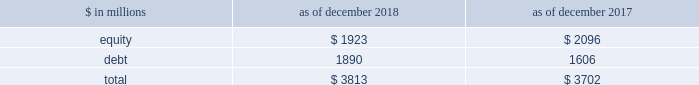The goldman sachs group , inc .
And subsidiaries management 2019s discussion and analysis during periods in which we have significantly more positive net revenue days than net revenue loss days , we expect to have fewer var exceptions because , under normal conditions , our business model generally produces positive net revenues .
In periods in which our franchise revenues are adversely affected , we generally have more loss days , resulting in more var exceptions .
The daily net revenues for positions included in var used to determine var exceptions reflect the impact of any intraday activity , including bid/offer net revenues , which are more likely than not to be positive by their nature .
Sensitivity measures certain portfolios and individual positions are not included in var because var is not the most appropriate risk measure .
Other sensitivity measures we use to analyze market risk are described below .
10% ( 10 % ) sensitivity measures .
The table below presents market risk by asset category for positions accounted for at fair value , that are not included in var. .
In the table above : 2030 the market risk of these positions is determined by estimating the potential reduction in net revenues of a 10% ( 10 % ) decline in the value of these positions .
2030 equity positions relate to private and restricted public equity securities , including interests in funds that invest in corporate equities and real estate and interests in hedge funds .
2030 debt positions include interests in funds that invest in corporate mezzanine and senior debt instruments , loans backed by commercial and residential real estate , corporate bank loans and other corporate debt , including acquired portfolios of distressed loans .
2030 funded equity and debt positions are included in our consolidated statements of financial condition in financial instruments owned .
See note 6 to the consolidated financial statements for further information about cash instruments .
2030 these measures do not reflect the diversification effect across asset categories or across other market risk measures .
Credit spread sensitivity on derivatives and financial liabilities .
Var excludes the impact of changes in counterparty and our own credit spreads on derivatives , as well as changes in our own credit spreads ( debt valuation adjustment ) on financial liabilities for which the fair value option was elected .
The estimated sensitivity to a one basis point increase in credit spreads ( counterparty and our own ) on derivatives was a gain of $ 3 million ( including hedges ) as of both december 2018 and december 2017 .
In addition , the estimated sensitivity to a one basis point increase in our own credit spreads on financial liabilities for which the fair value option was elected was a gain of $ 41 million as of december 2018 and $ 35 million as of december 2017 .
However , the actual net impact of a change in our own credit spreads is also affected by the liquidity , duration and convexity ( as the sensitivity is not linear to changes in yields ) of those financial liabilities for which the fair value option was elected , as well as the relative performance of any hedges undertaken .
Interest rate sensitivity .
Loans receivable were $ 80.59 billion as of december 2018 and $ 65.93 billion as of december 2017 , substantially all of which had floating interest rates .
The estimated sensitivity to a 100 basis point increase in interest rates on such loans was $ 607 million as of december 2018 and $ 527 million as of december 2017 , of additional interest income over a twelve-month period , which does not take into account the potential impact of an increase in costs to fund such loans .
See note 9 to the consolidated financial statements for further information about loans receivable .
Other market risk considerations as of both december 2018 and december 2017 , we had commitments and held loans for which we have obtained credit loss protection from sumitomo mitsui financial group , inc .
See note 18 to the consolidated financial statements for further information about such lending commitments .
In addition , we make investments in securities that are accounted for as available-for-sale and included in financial instruments owned in the consolidated statements of financial condition .
See note 6 to the consolidated financial statements for further information .
We also make investments accounted for under the equity method and we also make direct investments in real estate , both of which are included in other assets .
Direct investments in real estate are accounted for at cost less accumulated depreciation .
See note 13 to the consolidated financial statements for further information about other assets .
92 goldman sachs 2018 form 10-k .
For asset category for positions accounted for at fair value , that are not included in var , in millions for 2018 and 2017 , what was the maximum debt value? 
Computations: table_max(debt, none)
Answer: 1890.0. 